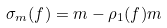<formula> <loc_0><loc_0><loc_500><loc_500>\sigma _ { m } ( f ) = m - \rho _ { 1 } ( f ) m</formula> 